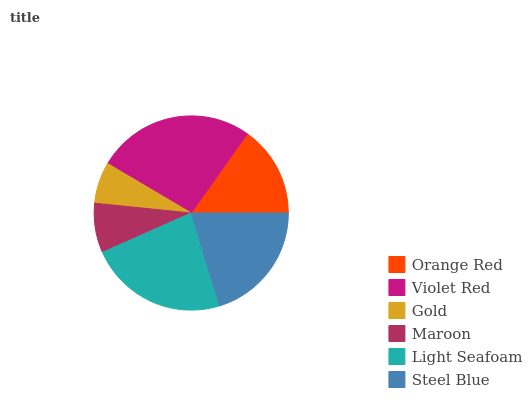Is Gold the minimum?
Answer yes or no. Yes. Is Violet Red the maximum?
Answer yes or no. Yes. Is Violet Red the minimum?
Answer yes or no. No. Is Gold the maximum?
Answer yes or no. No. Is Violet Red greater than Gold?
Answer yes or no. Yes. Is Gold less than Violet Red?
Answer yes or no. Yes. Is Gold greater than Violet Red?
Answer yes or no. No. Is Violet Red less than Gold?
Answer yes or no. No. Is Steel Blue the high median?
Answer yes or no. Yes. Is Orange Red the low median?
Answer yes or no. Yes. Is Light Seafoam the high median?
Answer yes or no. No. Is Light Seafoam the low median?
Answer yes or no. No. 